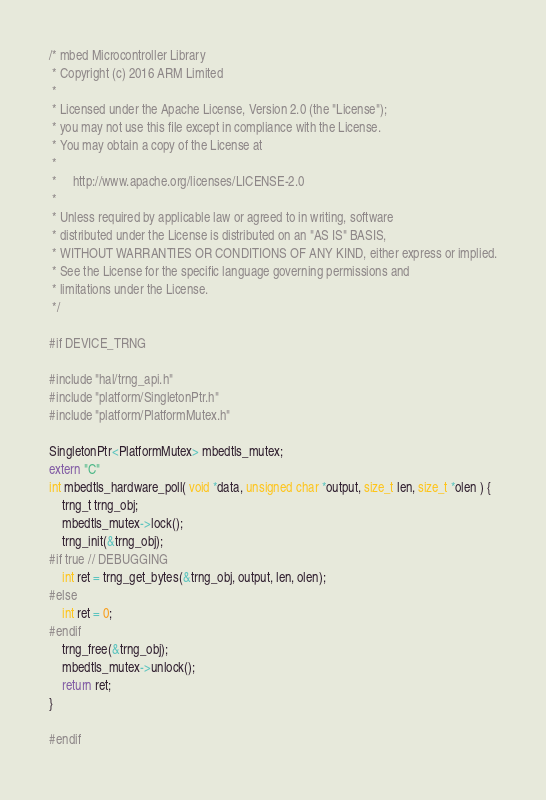Convert code to text. <code><loc_0><loc_0><loc_500><loc_500><_C++_>/* mbed Microcontroller Library
 * Copyright (c) 2016 ARM Limited
 *
 * Licensed under the Apache License, Version 2.0 (the "License");
 * you may not use this file except in compliance with the License.
 * You may obtain a copy of the License at
 *
 *     http://www.apache.org/licenses/LICENSE-2.0
 *
 * Unless required by applicable law or agreed to in writing, software
 * distributed under the License is distributed on an "AS IS" BASIS,
 * WITHOUT WARRANTIES OR CONDITIONS OF ANY KIND, either express or implied.
 * See the License for the specific language governing permissions and
 * limitations under the License.
 */

#if DEVICE_TRNG

#include "hal/trng_api.h"
#include "platform/SingletonPtr.h"
#include "platform/PlatformMutex.h"

SingletonPtr<PlatformMutex> mbedtls_mutex;
extern "C"
int mbedtls_hardware_poll( void *data, unsigned char *output, size_t len, size_t *olen ) {
    trng_t trng_obj;
    mbedtls_mutex->lock();
    trng_init(&trng_obj);
#if true // DEBUGGING
    int ret = trng_get_bytes(&trng_obj, output, len, olen);
#else
    int ret = 0;
#endif
    trng_free(&trng_obj);
    mbedtls_mutex->unlock();
    return ret;
}

#endif
</code> 